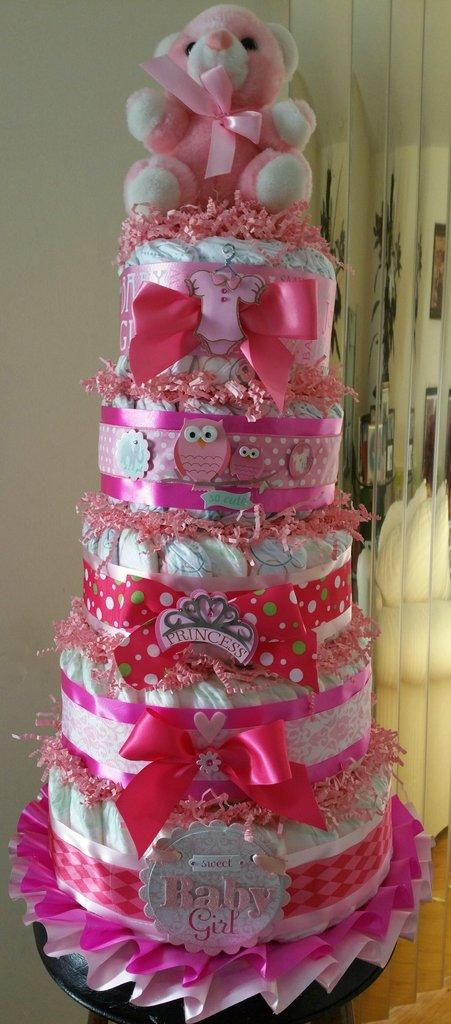What is the main subject of the image? There is a cake in the image. Is there anything placed on top of the cake? Yes, there is a teddy bear on top of the cake. What can be seen in the background of the image? There is a wall visible in the background of the image. How much pleasure does the cake provide to the teddy bear in the image? There is no indication of the teddy bear's emotions or pleasure in the image, as it is a static representation. 